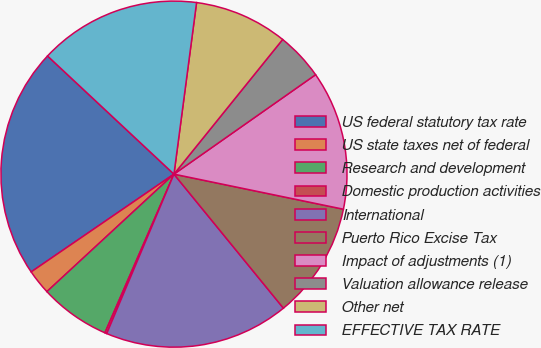Convert chart. <chart><loc_0><loc_0><loc_500><loc_500><pie_chart><fcel>US federal statutory tax rate<fcel>US state taxes net of federal<fcel>Research and development<fcel>Domestic production activities<fcel>International<fcel>Puerto Rico Excise Tax<fcel>Impact of adjustments (1)<fcel>Valuation allowance release<fcel>Other net<fcel>EFFECTIVE TAX RATE<nl><fcel>21.52%<fcel>2.32%<fcel>6.59%<fcel>0.18%<fcel>17.25%<fcel>10.85%<fcel>12.99%<fcel>4.45%<fcel>8.72%<fcel>15.12%<nl></chart> 